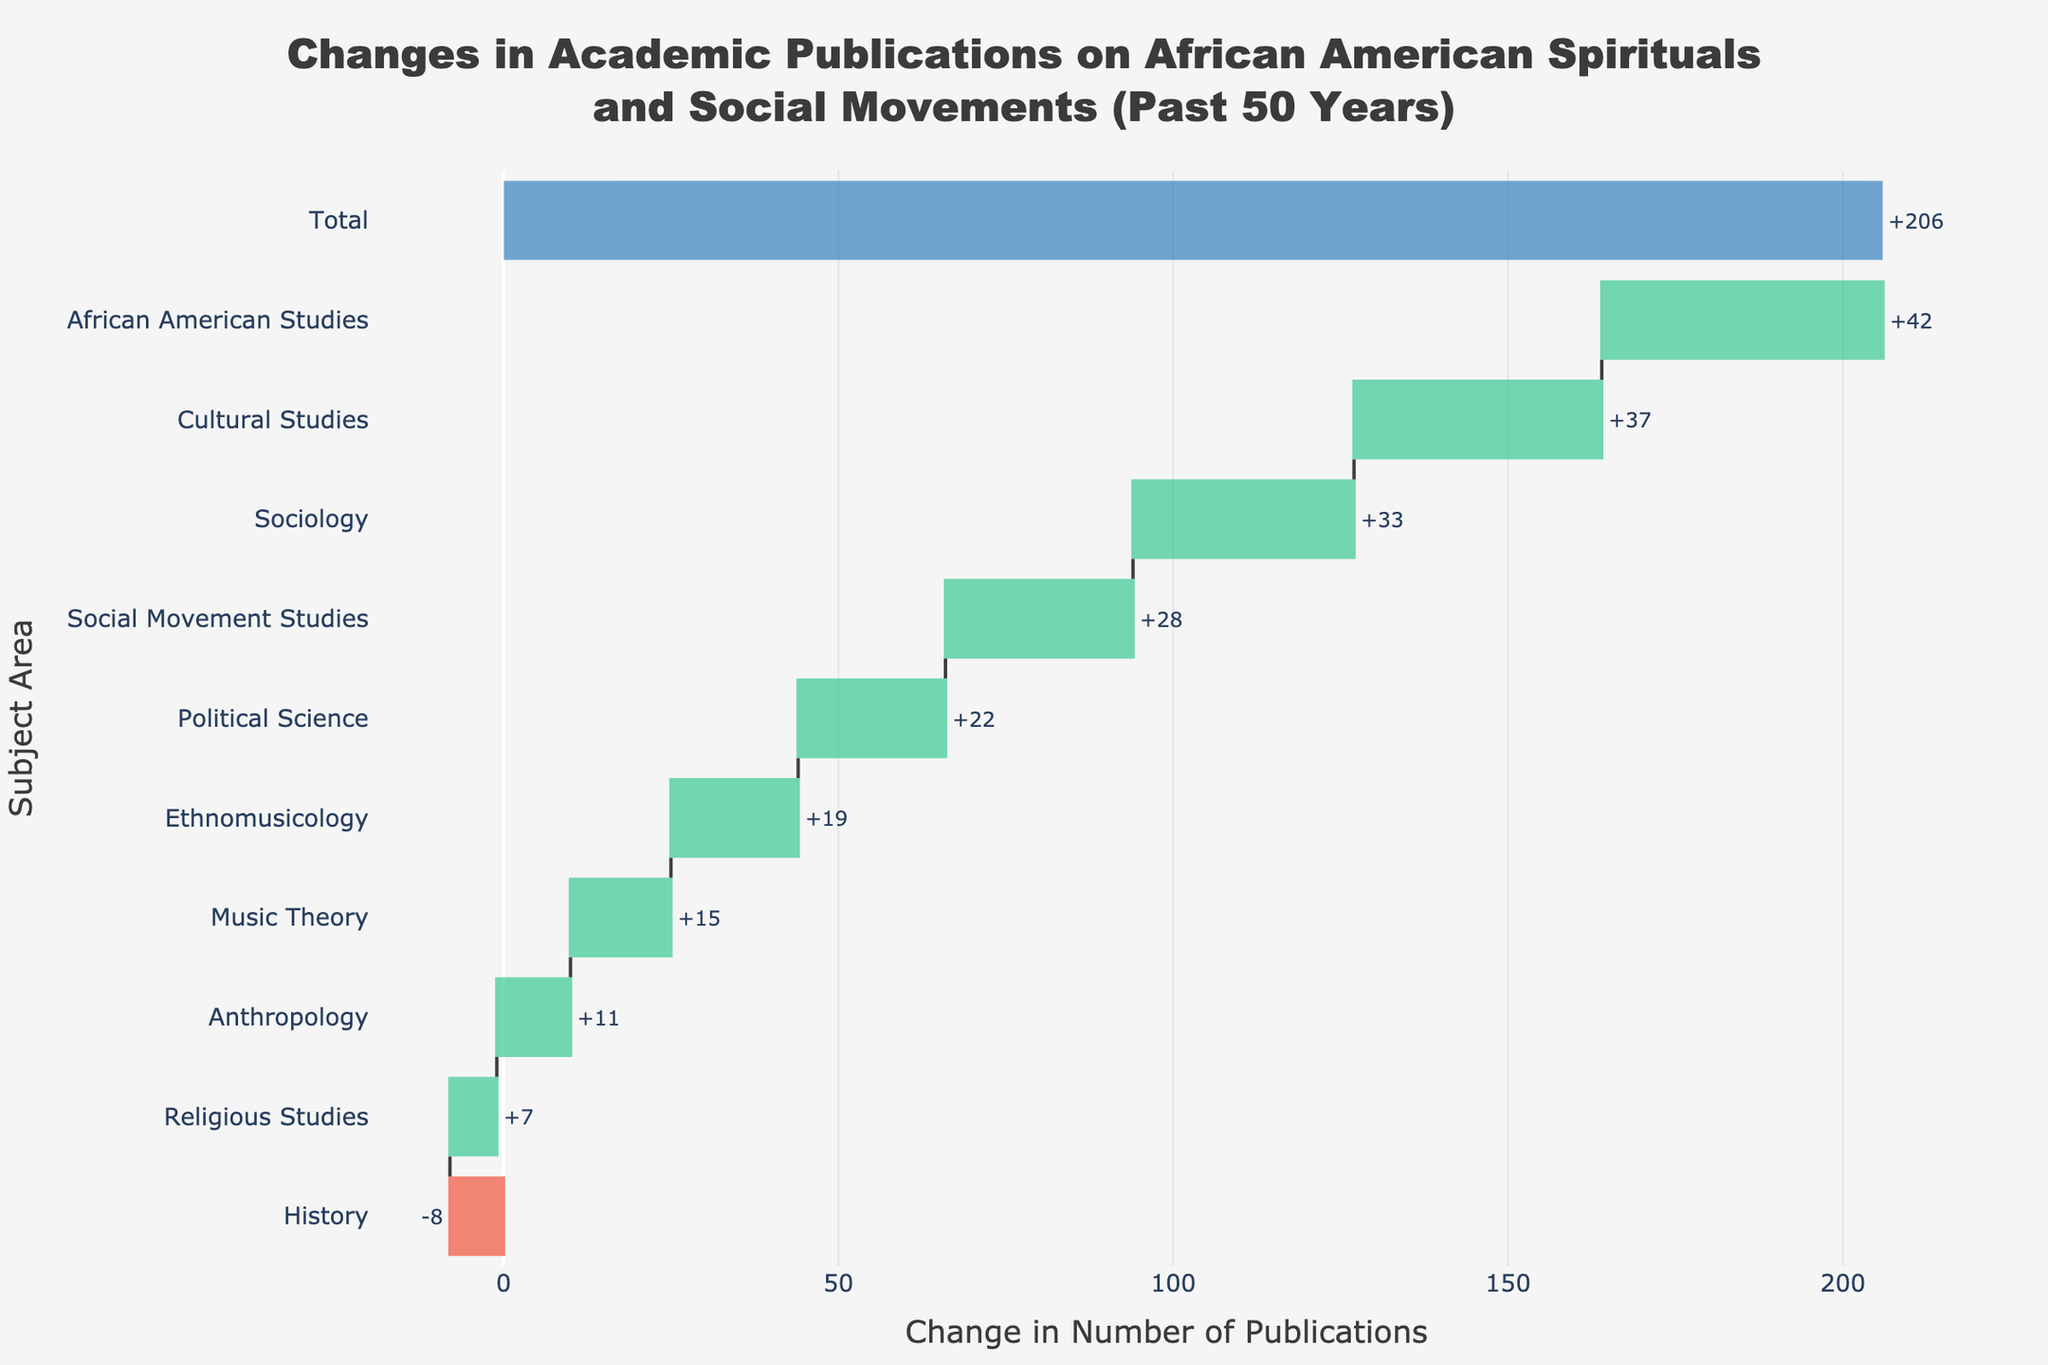What is the title of the figure? The title can be found at the top of the figure. It states the main idea or content being presented in the chart.
Answer: Changes in Academic Publications on African American Spirituals and Social Movements (Past 50 Years) Which subject area experienced the largest increase in the number of publications? Look for the subject with the highest positive bar length on the X-axis.
Answer: African American Studies Which subject area experienced a decrease in the number of publications? Look for the subject with the negative bar on the X-axis, indicating a reduction in publications.
Answer: History How many subject areas showed an increase in the number of publications? Count the number of bars with positive change values.
Answer: 9 What is the total change in the number of academic publications across all subject areas? Find the bar labeled "Total" and add up all the changes from each subject area to verify.
Answer: 206 What is the average increase in publications across all subject areas that showed an increase? First, sum all positive changes, then divide by the number of subjects that had an increase. The total positive change is 214 from 9 subjects: (15 + 42 + 28 + 33 + 19 + 7 + 11 + 22 + 37)/9.
Answer: 214/9 ≈ 23.78 Which two subject areas had the closest increase in publications? Identify the two subject areas with the closest values by comparing the positive changes.
Answer: Political Science and Ethnomusicology (22 and 19) What is the difference in the number of publications between African American Studies and Political Science? Subtract the change value of Political Science from that of African American Studies: 42 - 22.
Answer: 20 Which subject area had the second-largest increase in publications? Identify the subject area with the second-highest positive change by looking at the bar lengths and their values.
Answer: Cultural Studies What is the change in the number of publications for Sociology? Identify the bar corresponding to Sociology on the Y-axis and note the value.
Answer: +33 